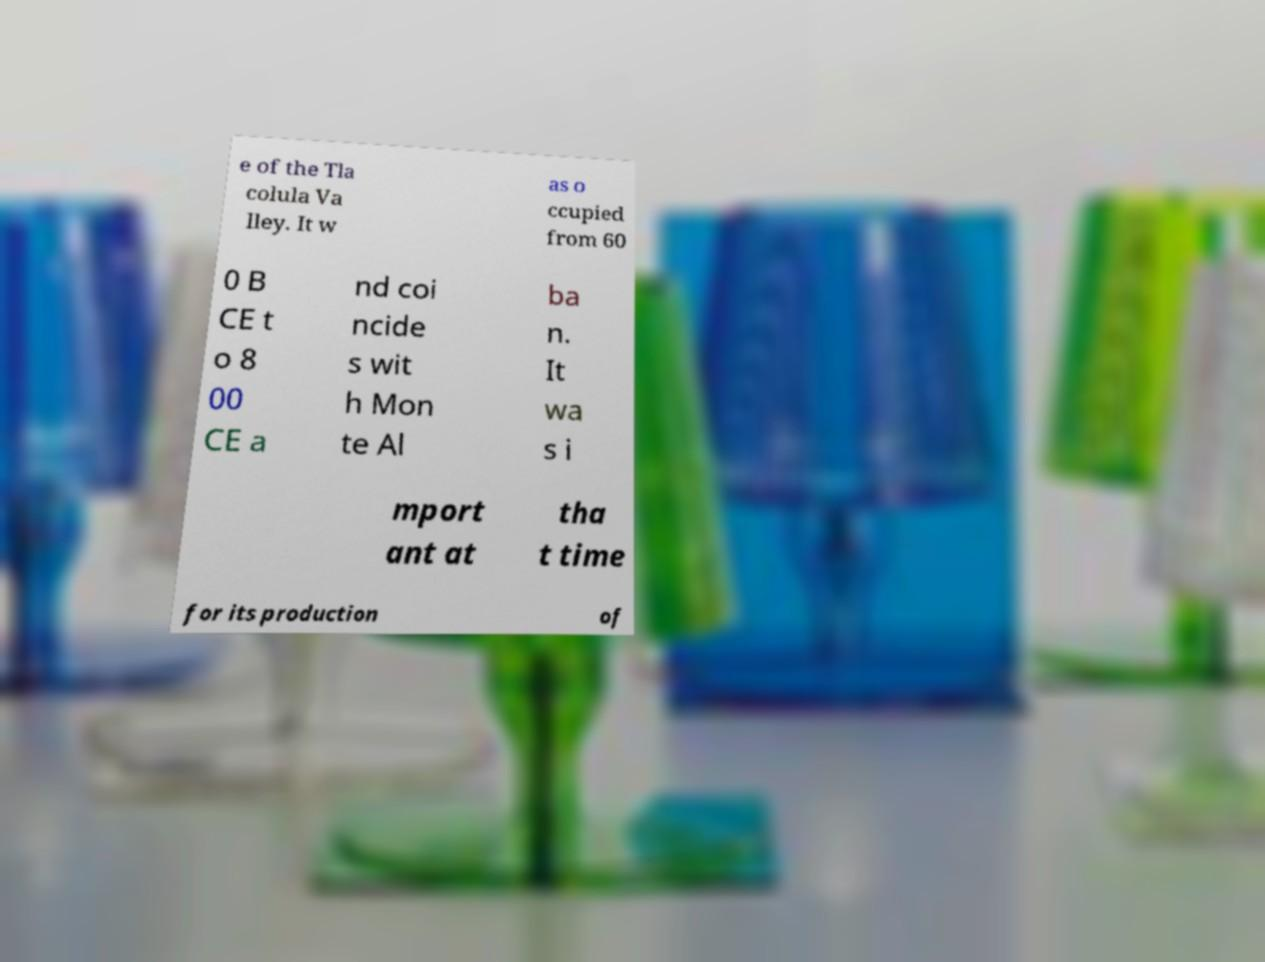Could you extract and type out the text from this image? e of the Tla colula Va lley. It w as o ccupied from 60 0 B CE t o 8 00 CE a nd coi ncide s wit h Mon te Al ba n. It wa s i mport ant at tha t time for its production of 